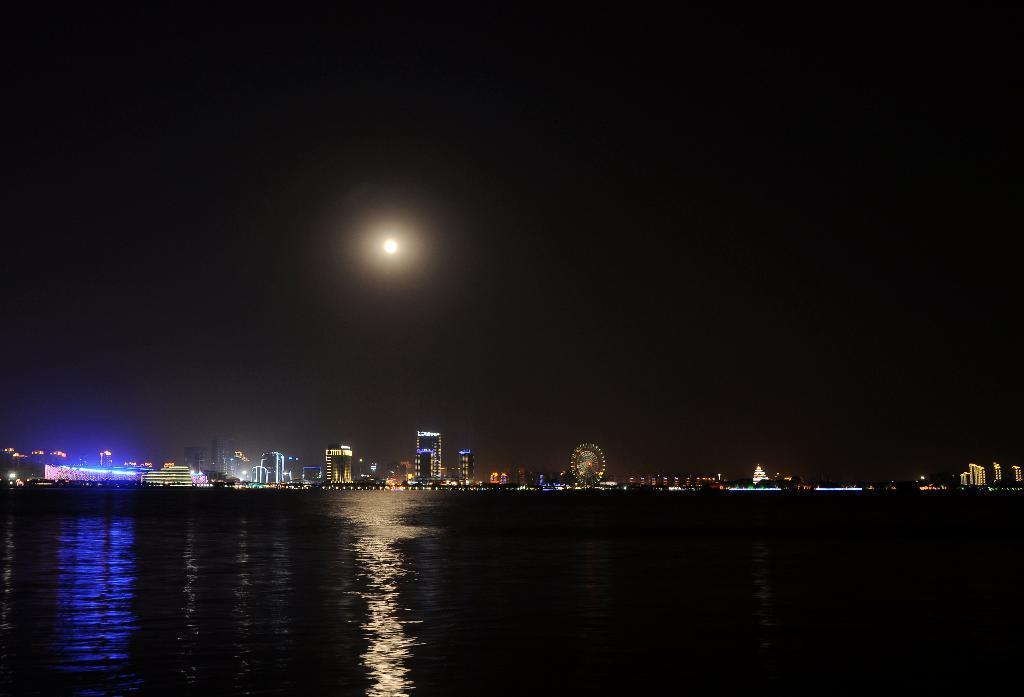Describe this image in one or two sentences. In this picture we can see water at the bottom, in the background there are some buildings, a giant wheel and some lights, there is sky at the top of the picture, we can see moon here. 